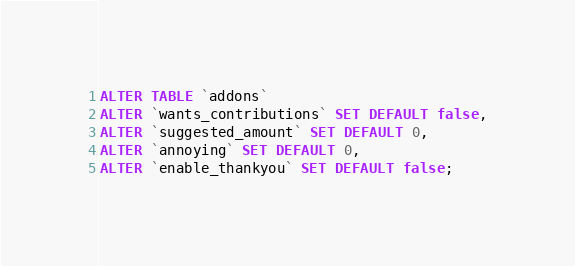<code> <loc_0><loc_0><loc_500><loc_500><_SQL_>ALTER TABLE `addons`
ALTER `wants_contributions` SET DEFAULT false,
ALTER `suggested_amount` SET DEFAULT 0,
ALTER `annoying` SET DEFAULT 0,
ALTER `enable_thankyou` SET DEFAULT false;
</code> 